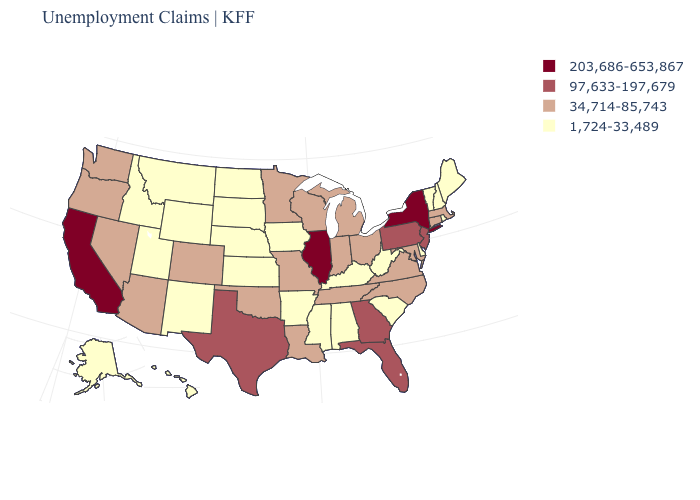What is the lowest value in the MidWest?
Write a very short answer. 1,724-33,489. How many symbols are there in the legend?
Quick response, please. 4. Does the first symbol in the legend represent the smallest category?
Quick response, please. No. Among the states that border Minnesota , which have the highest value?
Give a very brief answer. Wisconsin. What is the value of Iowa?
Quick response, please. 1,724-33,489. Name the states that have a value in the range 203,686-653,867?
Answer briefly. California, Illinois, New York. How many symbols are there in the legend?
Short answer required. 4. Does Florida have the highest value in the South?
Give a very brief answer. Yes. Name the states that have a value in the range 1,724-33,489?
Answer briefly. Alabama, Alaska, Arkansas, Delaware, Hawaii, Idaho, Iowa, Kansas, Kentucky, Maine, Mississippi, Montana, Nebraska, New Hampshire, New Mexico, North Dakota, Rhode Island, South Carolina, South Dakota, Utah, Vermont, West Virginia, Wyoming. Name the states that have a value in the range 34,714-85,743?
Short answer required. Arizona, Colorado, Connecticut, Indiana, Louisiana, Maryland, Massachusetts, Michigan, Minnesota, Missouri, Nevada, North Carolina, Ohio, Oklahoma, Oregon, Tennessee, Virginia, Washington, Wisconsin. Does the first symbol in the legend represent the smallest category?
Be succinct. No. What is the value of Montana?
Be succinct. 1,724-33,489. What is the value of Massachusetts?
Short answer required. 34,714-85,743. Which states have the lowest value in the USA?
Write a very short answer. Alabama, Alaska, Arkansas, Delaware, Hawaii, Idaho, Iowa, Kansas, Kentucky, Maine, Mississippi, Montana, Nebraska, New Hampshire, New Mexico, North Dakota, Rhode Island, South Carolina, South Dakota, Utah, Vermont, West Virginia, Wyoming. Which states have the highest value in the USA?
Keep it brief. California, Illinois, New York. 